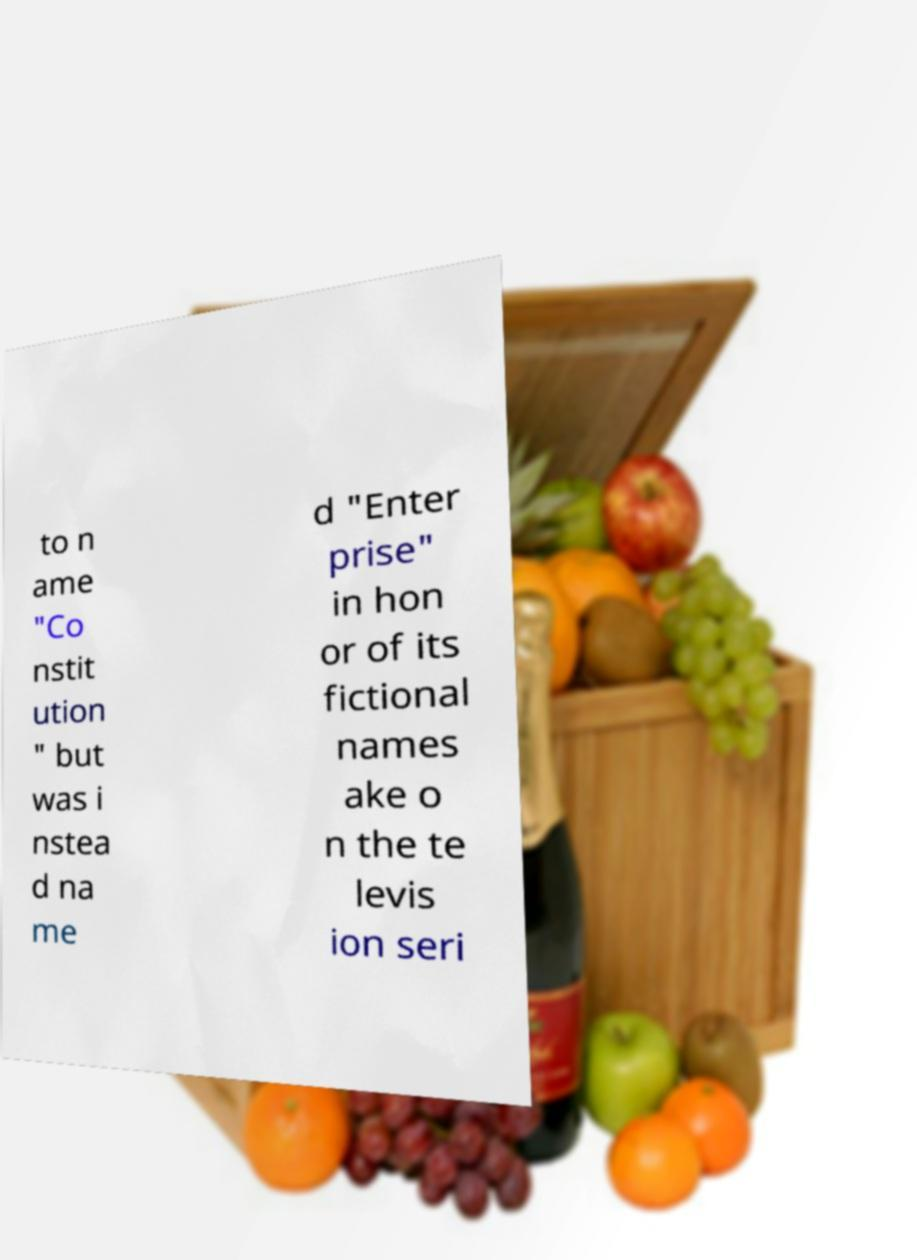There's text embedded in this image that I need extracted. Can you transcribe it verbatim? to n ame "Co nstit ution " but was i nstea d na me d "Enter prise" in hon or of its fictional names ake o n the te levis ion seri 